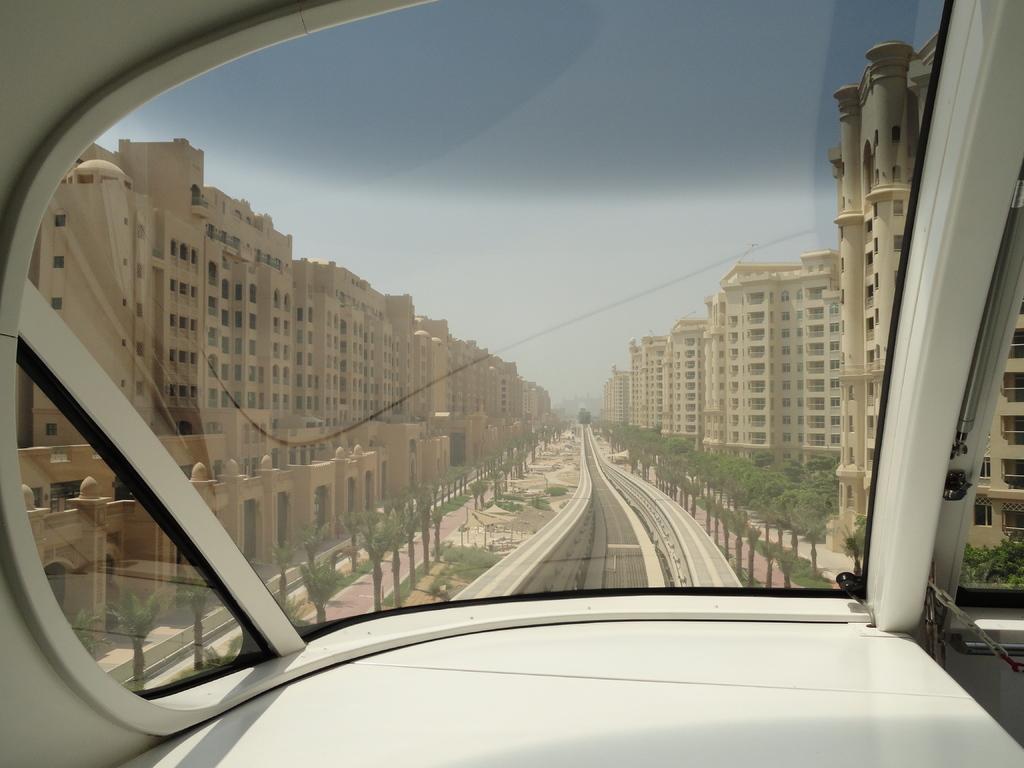In one or two sentences, can you explain what this image depicts? This is a picture captured from inside a vehicle, and in the background there are buildings, plants, trees, poles, sky 